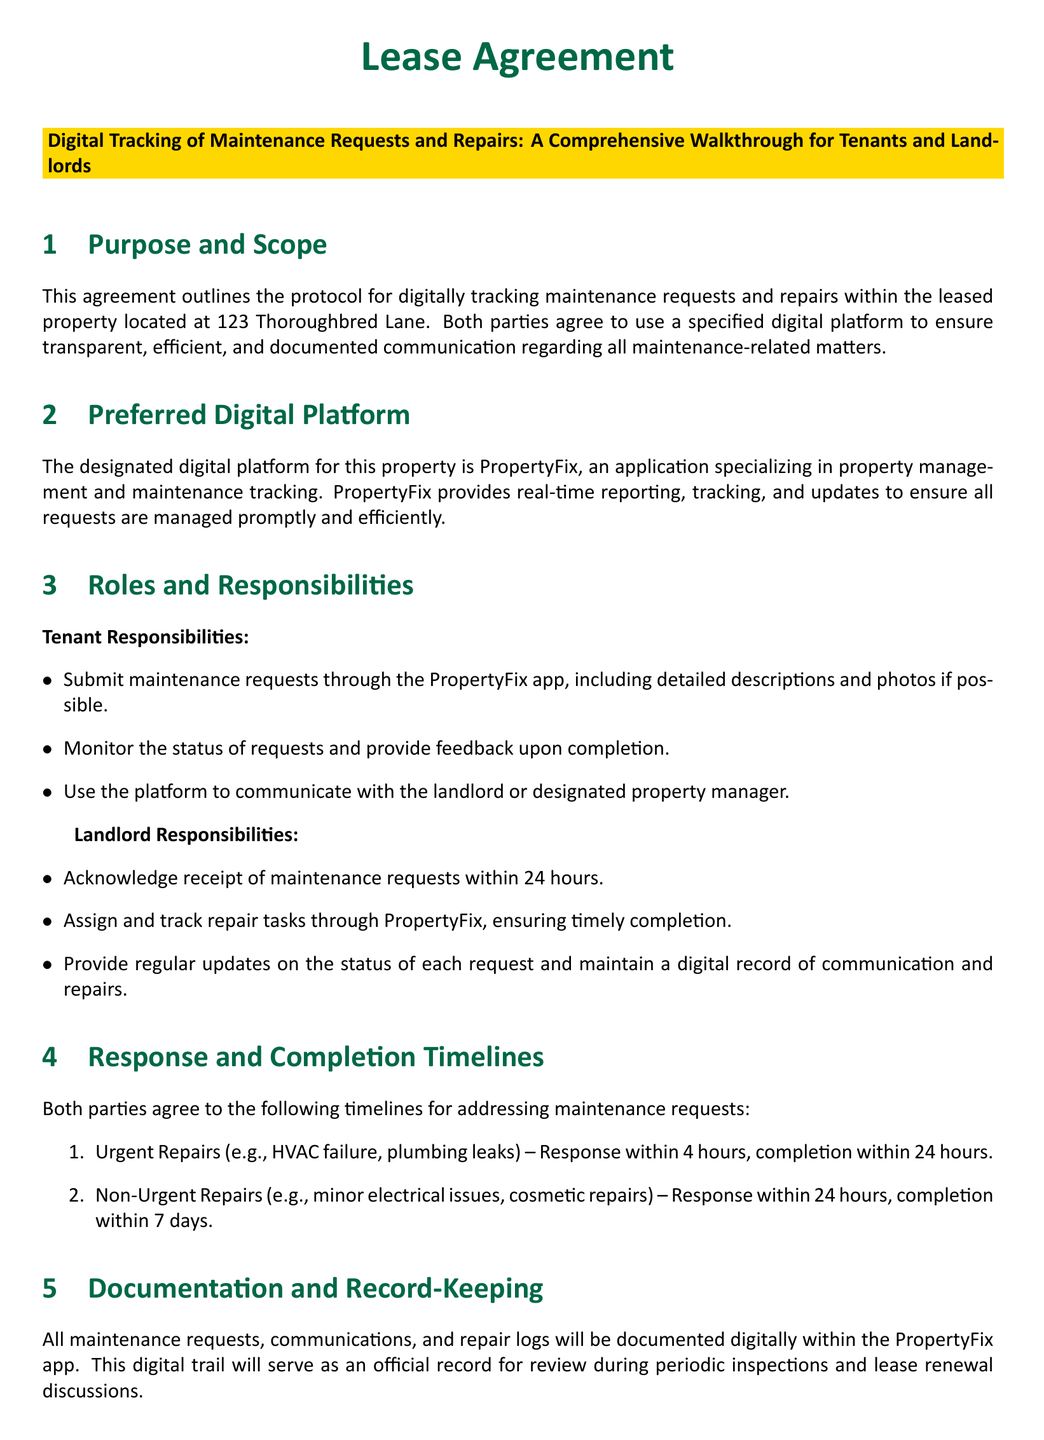What is the address of the leased property? The address of the leased property is stated in the Purpose and Scope section of the document.
Answer: 123 Thoroughbred Lane What is the name of the designated digital platform? The name of the digital platform is mentioned in the Preferred Digital Platform section.
Answer: PropertyFix What is the response time for urgent repairs? The response time for urgent repairs is outlined in the Response and Completion Timelines section.
Answer: 4 hours How long does the landlord have to acknowledge maintenance requests? The acknowledgment time for maintenance requests is specified in the Landlord Responsibilities section.
Answer: 24 hours What is the documentation method for maintenance requests? The documentation method is described in the Documentation and Record-Keeping section.
Answer: PropertyFix app What type of support is available for using the platform? The type of support available is mentioned in the Technology Support and Training section.
Answer: 24/7 customer support What is the completion timeline for non-urgent repairs? The completion timeline for non-urgent repairs is stated in the Response and Completion Timelines section.
Answer: 7 days What protocol is established for privacy? The protocol for privacy is outlined in the Privacy and Security section.
Answer: Encrypted communication What is included in the tenant's responsibilities? The tenant's responsibilities are detailed in the Tenant Responsibilities section.
Answer: Submit maintenance requests 